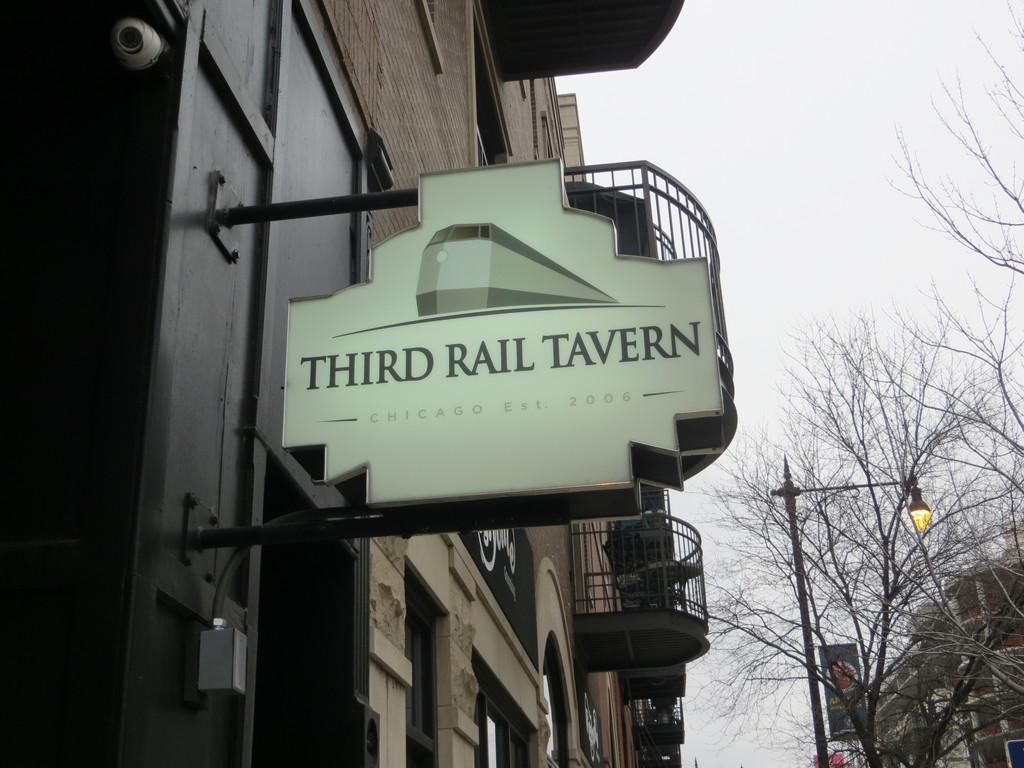Please provide a concise description of this image. In this picture we can see buildings with windows, name board, banner, trees, pole, lamp and in the background we can see the sky. 